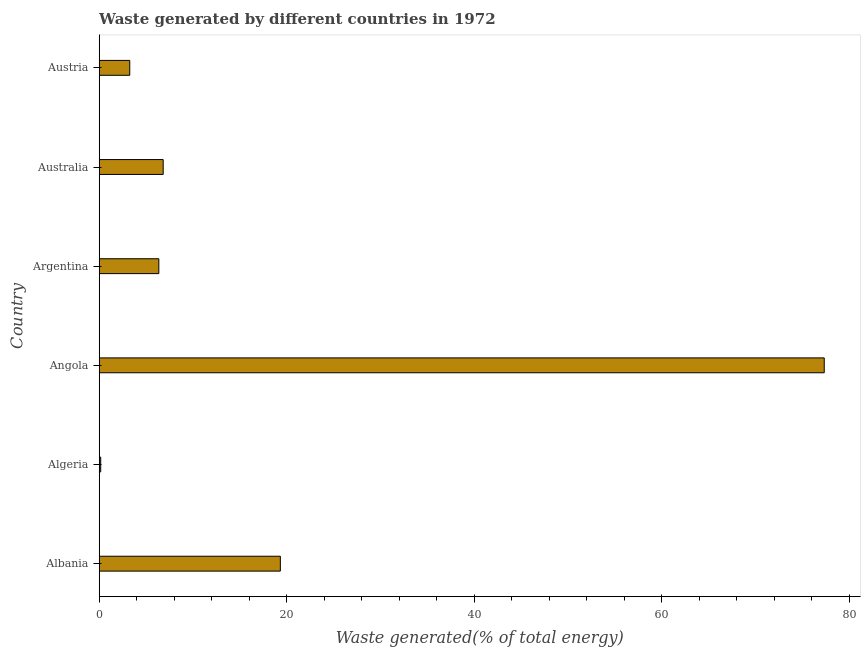Does the graph contain any zero values?
Your answer should be very brief. No. What is the title of the graph?
Keep it short and to the point. Waste generated by different countries in 1972. What is the label or title of the X-axis?
Offer a terse response. Waste generated(% of total energy). What is the label or title of the Y-axis?
Ensure brevity in your answer.  Country. What is the amount of waste generated in Albania?
Make the answer very short. 19.32. Across all countries, what is the maximum amount of waste generated?
Keep it short and to the point. 77.33. Across all countries, what is the minimum amount of waste generated?
Offer a very short reply. 0.16. In which country was the amount of waste generated maximum?
Keep it short and to the point. Angola. In which country was the amount of waste generated minimum?
Make the answer very short. Algeria. What is the sum of the amount of waste generated?
Offer a terse response. 113.24. What is the difference between the amount of waste generated in Algeria and Australia?
Provide a short and direct response. -6.66. What is the average amount of waste generated per country?
Ensure brevity in your answer.  18.87. What is the median amount of waste generated?
Offer a very short reply. 6.59. What is the ratio of the amount of waste generated in Angola to that in Argentina?
Offer a very short reply. 12.16. Is the difference between the amount of waste generated in Albania and Algeria greater than the difference between any two countries?
Make the answer very short. No. What is the difference between the highest and the second highest amount of waste generated?
Your answer should be compact. 58.01. Is the sum of the amount of waste generated in Albania and Australia greater than the maximum amount of waste generated across all countries?
Keep it short and to the point. No. What is the difference between the highest and the lowest amount of waste generated?
Your answer should be very brief. 77.17. In how many countries, is the amount of waste generated greater than the average amount of waste generated taken over all countries?
Your answer should be very brief. 2. How many bars are there?
Offer a very short reply. 6. How many countries are there in the graph?
Your answer should be compact. 6. What is the difference between two consecutive major ticks on the X-axis?
Keep it short and to the point. 20. Are the values on the major ticks of X-axis written in scientific E-notation?
Provide a succinct answer. No. What is the Waste generated(% of total energy) of Albania?
Keep it short and to the point. 19.32. What is the Waste generated(% of total energy) of Algeria?
Make the answer very short. 0.16. What is the Waste generated(% of total energy) of Angola?
Offer a terse response. 77.33. What is the Waste generated(% of total energy) in Argentina?
Offer a very short reply. 6.36. What is the Waste generated(% of total energy) in Australia?
Offer a terse response. 6.82. What is the Waste generated(% of total energy) in Austria?
Your response must be concise. 3.26. What is the difference between the Waste generated(% of total energy) in Albania and Algeria?
Provide a short and direct response. 19.16. What is the difference between the Waste generated(% of total energy) in Albania and Angola?
Your answer should be compact. -58.01. What is the difference between the Waste generated(% of total energy) in Albania and Argentina?
Give a very brief answer. 12.96. What is the difference between the Waste generated(% of total energy) in Albania and Australia?
Offer a very short reply. 12.5. What is the difference between the Waste generated(% of total energy) in Albania and Austria?
Offer a very short reply. 16.06. What is the difference between the Waste generated(% of total energy) in Algeria and Angola?
Your response must be concise. -77.17. What is the difference between the Waste generated(% of total energy) in Algeria and Argentina?
Provide a succinct answer. -6.2. What is the difference between the Waste generated(% of total energy) in Algeria and Australia?
Provide a short and direct response. -6.66. What is the difference between the Waste generated(% of total energy) in Algeria and Austria?
Your answer should be compact. -3.1. What is the difference between the Waste generated(% of total energy) in Angola and Argentina?
Provide a succinct answer. 70.97. What is the difference between the Waste generated(% of total energy) in Angola and Australia?
Offer a very short reply. 70.51. What is the difference between the Waste generated(% of total energy) in Angola and Austria?
Provide a succinct answer. 74.07. What is the difference between the Waste generated(% of total energy) in Argentina and Australia?
Your answer should be very brief. -0.47. What is the difference between the Waste generated(% of total energy) in Argentina and Austria?
Your answer should be very brief. 3.1. What is the difference between the Waste generated(% of total energy) in Australia and Austria?
Ensure brevity in your answer.  3.57. What is the ratio of the Waste generated(% of total energy) in Albania to that in Algeria?
Keep it short and to the point. 121.36. What is the ratio of the Waste generated(% of total energy) in Albania to that in Argentina?
Your answer should be very brief. 3.04. What is the ratio of the Waste generated(% of total energy) in Albania to that in Australia?
Your response must be concise. 2.83. What is the ratio of the Waste generated(% of total energy) in Albania to that in Austria?
Offer a terse response. 5.93. What is the ratio of the Waste generated(% of total energy) in Algeria to that in Angola?
Provide a short and direct response. 0. What is the ratio of the Waste generated(% of total energy) in Algeria to that in Argentina?
Offer a terse response. 0.03. What is the ratio of the Waste generated(% of total energy) in Algeria to that in Australia?
Give a very brief answer. 0.02. What is the ratio of the Waste generated(% of total energy) in Algeria to that in Austria?
Provide a succinct answer. 0.05. What is the ratio of the Waste generated(% of total energy) in Angola to that in Argentina?
Your answer should be very brief. 12.16. What is the ratio of the Waste generated(% of total energy) in Angola to that in Australia?
Your response must be concise. 11.33. What is the ratio of the Waste generated(% of total energy) in Angola to that in Austria?
Your answer should be very brief. 23.75. What is the ratio of the Waste generated(% of total energy) in Argentina to that in Australia?
Your response must be concise. 0.93. What is the ratio of the Waste generated(% of total energy) in Argentina to that in Austria?
Your response must be concise. 1.95. What is the ratio of the Waste generated(% of total energy) in Australia to that in Austria?
Make the answer very short. 2.1. 